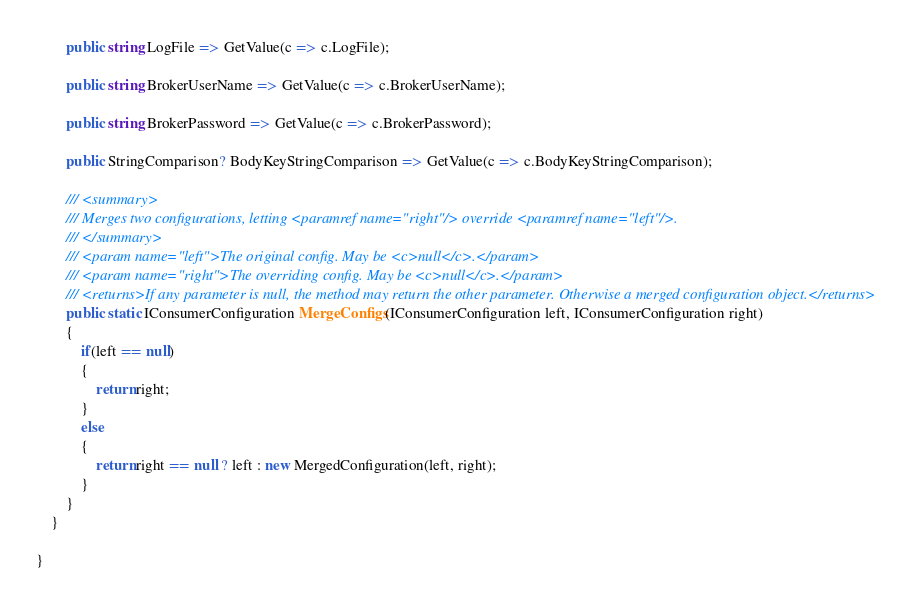Convert code to text. <code><loc_0><loc_0><loc_500><loc_500><_C#_>        public string LogFile => GetValue(c => c.LogFile);

        public string BrokerUserName => GetValue(c => c.BrokerUserName);

        public string BrokerPassword => GetValue(c => c.BrokerPassword);

        public StringComparison? BodyKeyStringComparison => GetValue(c => c.BodyKeyStringComparison);

        /// <summary>
        /// Merges two configurations, letting <paramref name="right"/> override <paramref name="left"/>.
        /// </summary>
        /// <param name="left">The original config. May be <c>null</c>.</param>
        /// <param name="right">The overriding config. May be <c>null</c>.</param>
        /// <returns>If any parameter is null, the method may return the other parameter. Otherwise a merged configuration object.</returns>
        public static IConsumerConfiguration MergeConfigs(IConsumerConfiguration left, IConsumerConfiguration right)
        {
            if(left == null)
            {
                return right;
            }
            else
            {
                return right == null ? left : new MergedConfiguration(left, right);
            }
        }
    }

}</code> 